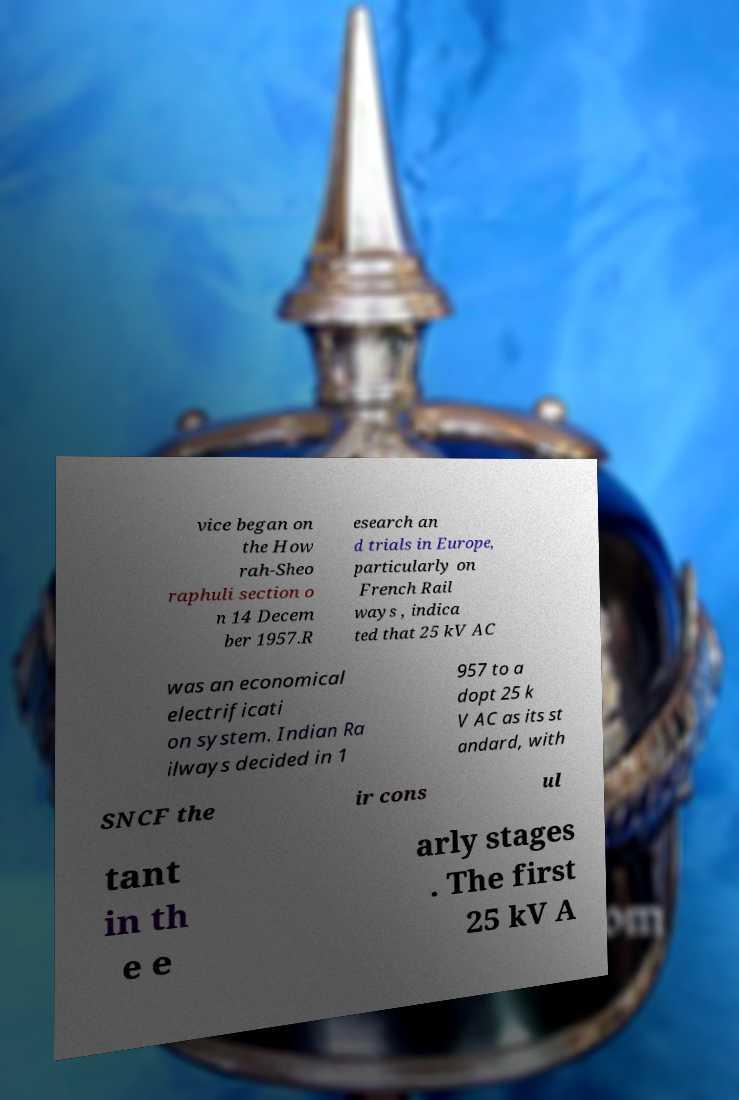I need the written content from this picture converted into text. Can you do that? vice began on the How rah-Sheo raphuli section o n 14 Decem ber 1957.R esearch an d trials in Europe, particularly on French Rail ways , indica ted that 25 kV AC was an economical electrificati on system. Indian Ra ilways decided in 1 957 to a dopt 25 k V AC as its st andard, with SNCF the ir cons ul tant in th e e arly stages . The first 25 kV A 